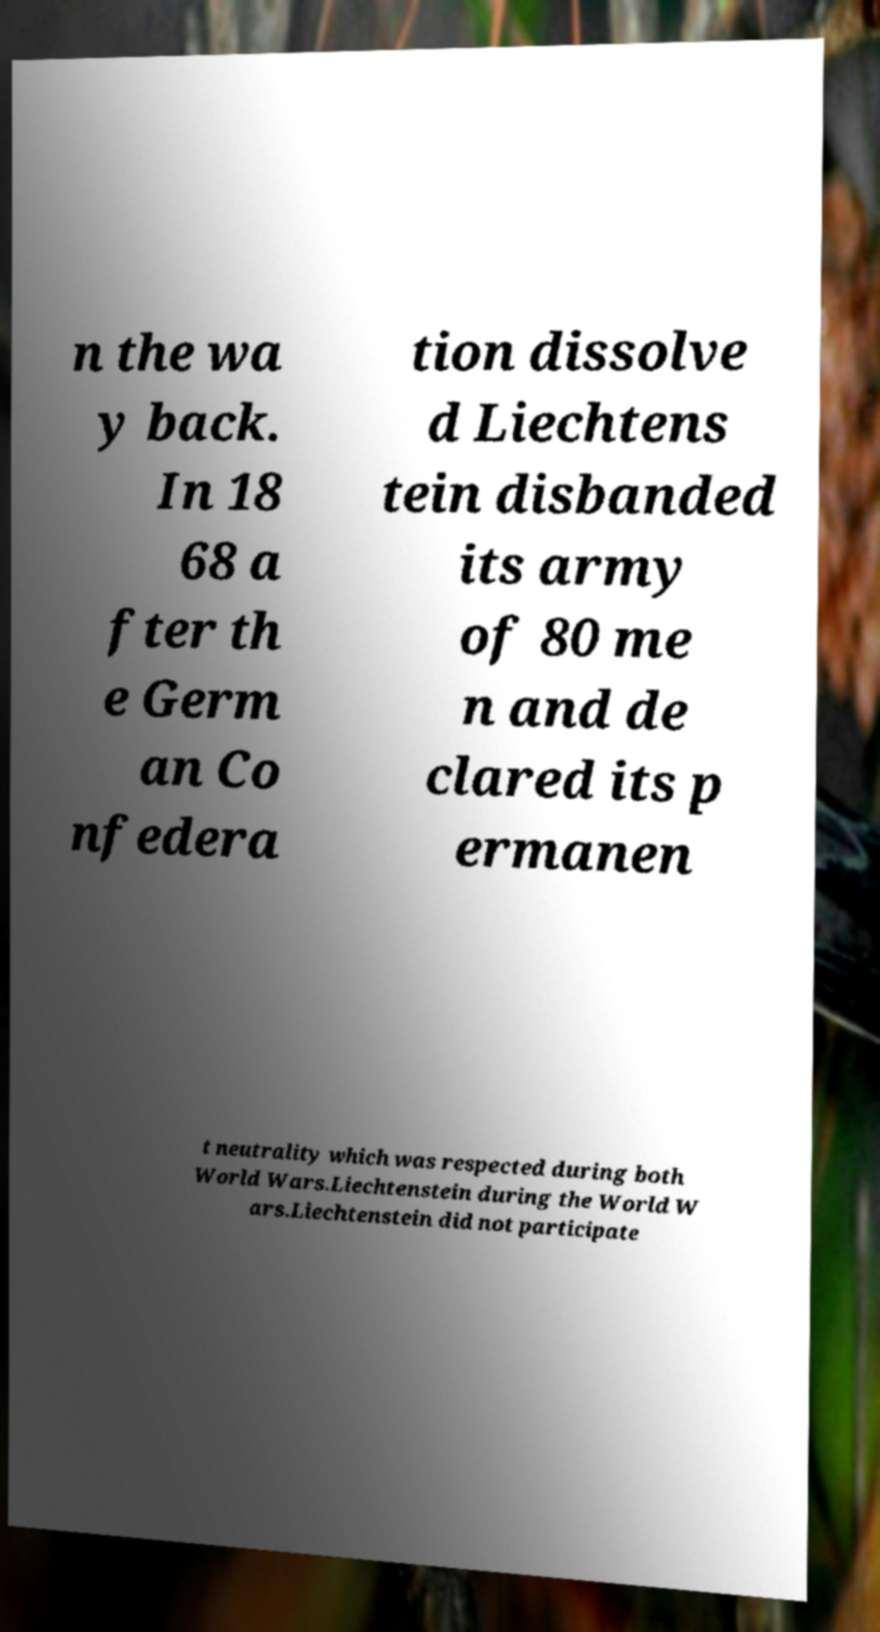Could you assist in decoding the text presented in this image and type it out clearly? n the wa y back. In 18 68 a fter th e Germ an Co nfedera tion dissolve d Liechtens tein disbanded its army of 80 me n and de clared its p ermanen t neutrality which was respected during both World Wars.Liechtenstein during the World W ars.Liechtenstein did not participate 